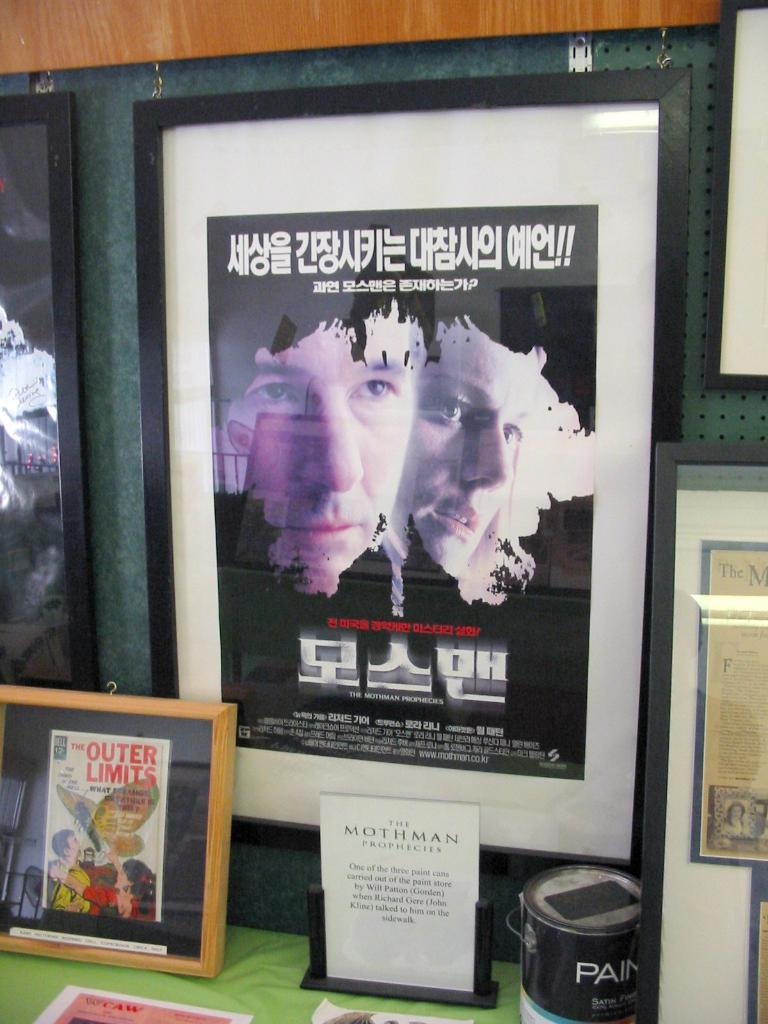<image>
Provide a brief description of the given image. A poster for the Mothman Prophecies is framed sitting on a table. 